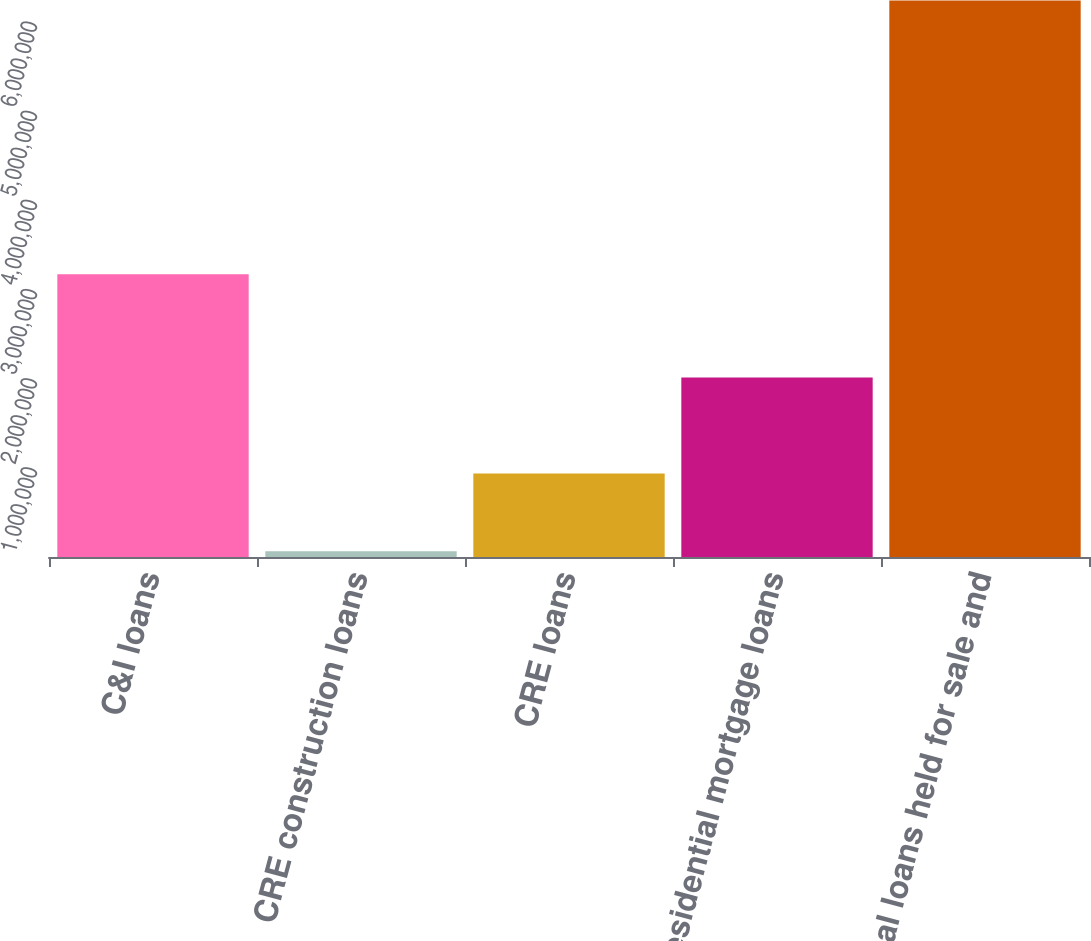Convert chart. <chart><loc_0><loc_0><loc_500><loc_500><bar_chart><fcel>C&I loans<fcel>CRE construction loans<fcel>CRE loans<fcel>Residential mortgage loans<fcel>Total loans held for sale and<nl><fcel>3.17309e+06<fcel>65512<fcel>937669<fcel>2.01368e+06<fcel>6.24201e+06<nl></chart> 